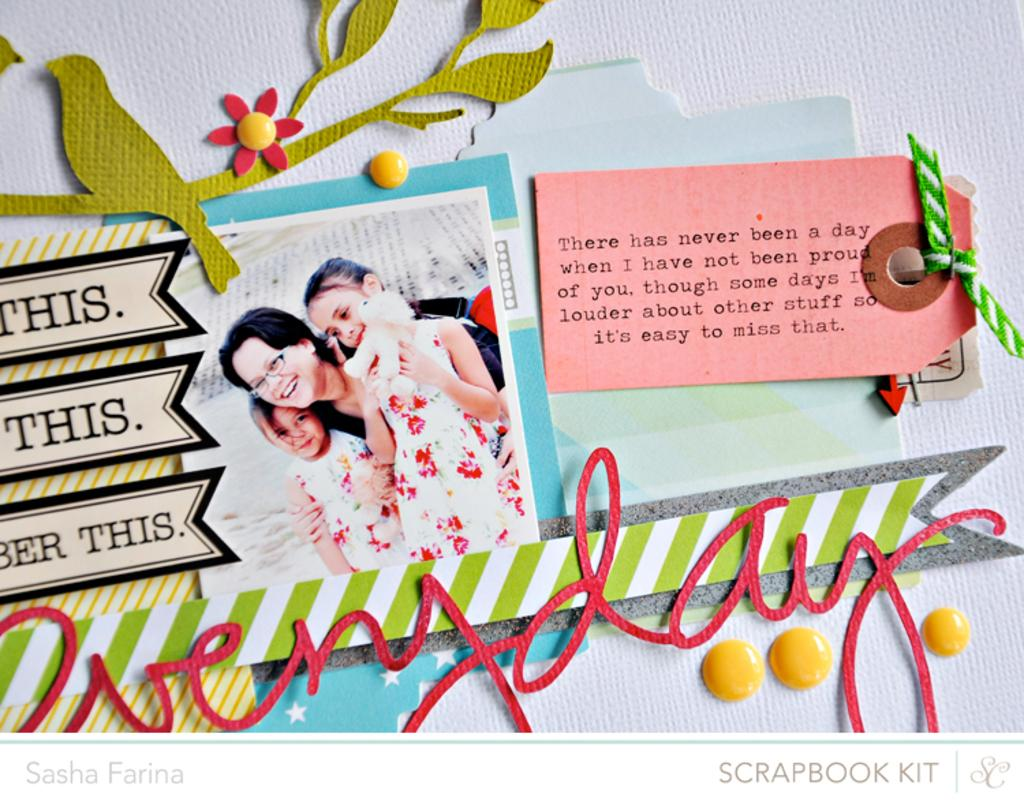What is the color of the surface in the image? The surface in the image is white. What is placed on the white surface? There are papers on the white surface. What can be seen in the picture on the white surface? There is a picture of multiple persons standing on the white surface. Are there any snakes visible on the white surface in the image? No, there are no snakes visible on the white surface in the image. What type of competition is taking place on the white surface in the image? There is no competition present in the image; it features papers and a picture of multiple persons standing on the white surface. 